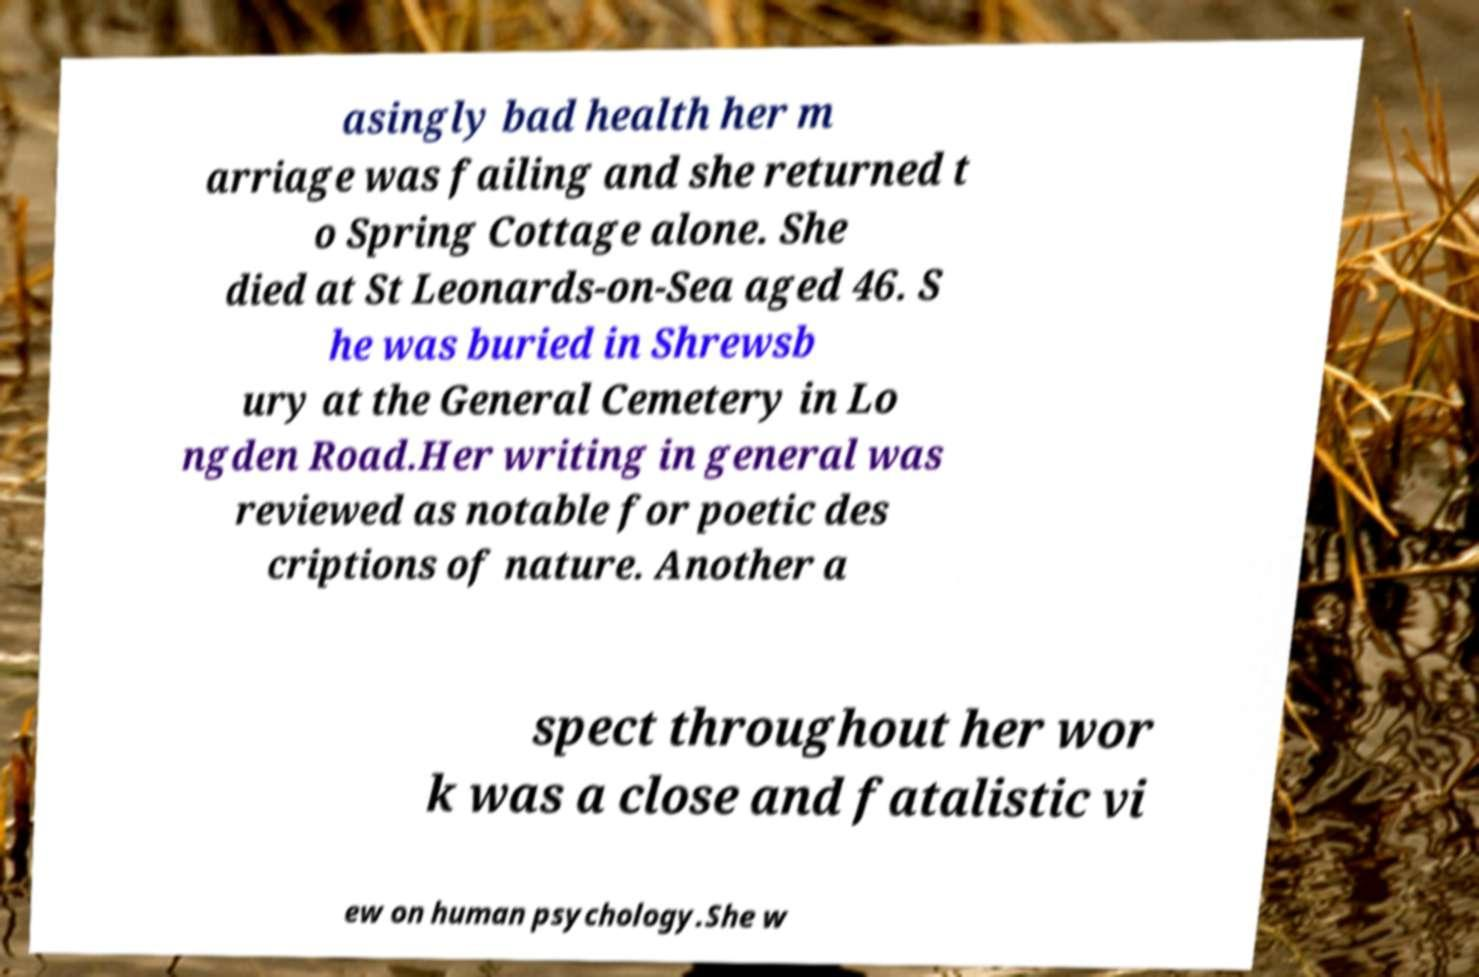For documentation purposes, I need the text within this image transcribed. Could you provide that? asingly bad health her m arriage was failing and she returned t o Spring Cottage alone. She died at St Leonards-on-Sea aged 46. S he was buried in Shrewsb ury at the General Cemetery in Lo ngden Road.Her writing in general was reviewed as notable for poetic des criptions of nature. Another a spect throughout her wor k was a close and fatalistic vi ew on human psychology.She w 